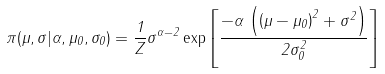Convert formula to latex. <formula><loc_0><loc_0><loc_500><loc_500>\pi ( \mu , \sigma | \alpha , \mu _ { 0 } , \sigma _ { 0 } ) = \frac { 1 } { Z } { \sigma } ^ { \alpha - 2 } \exp \left [ { { \frac { - \alpha \, \left ( \left ( \mu - \mu _ { 0 } \right ) ^ { 2 } + { \sigma } ^ { 2 } \right ) } { 2 \sigma _ { 0 } ^ { 2 } } } } \right ]</formula> 